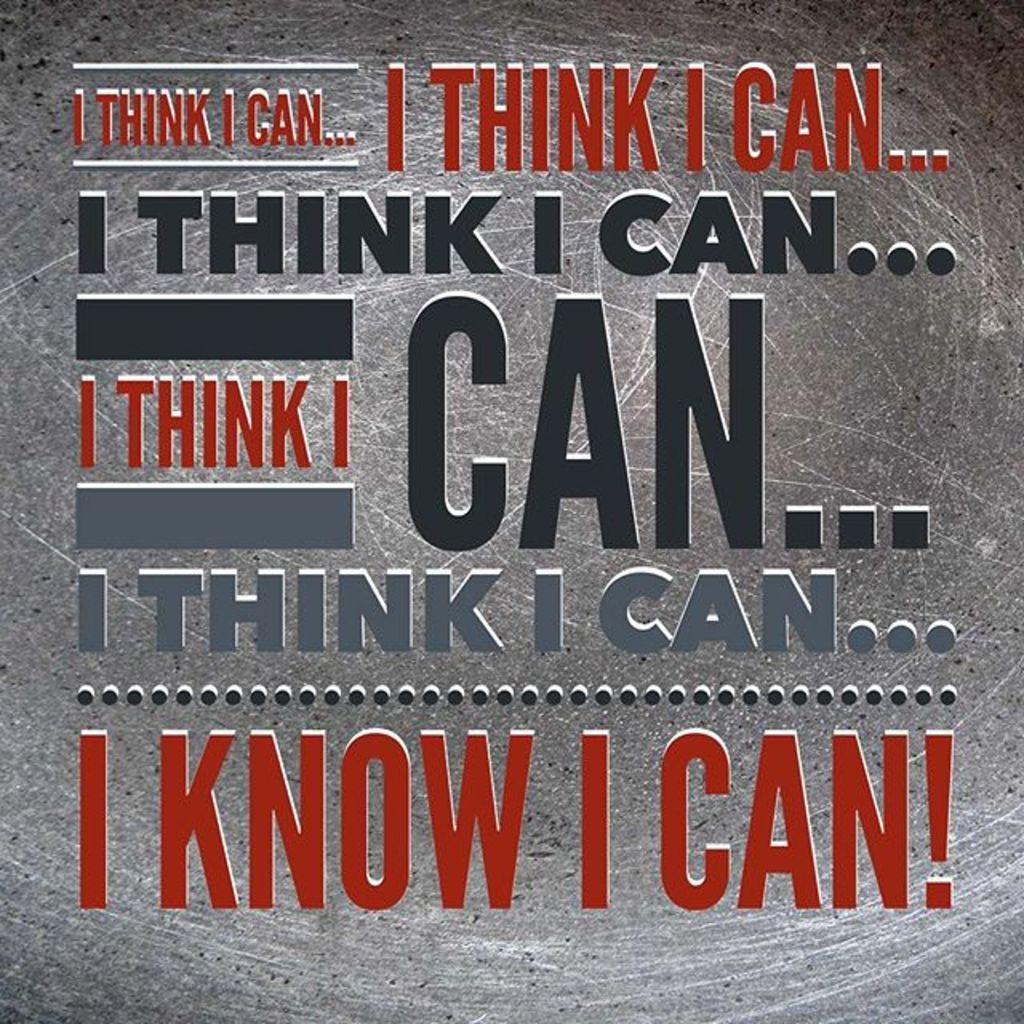What do you know at the bottom?
Offer a very short reply. I can. What do you think?
Provide a succinct answer. I can. 